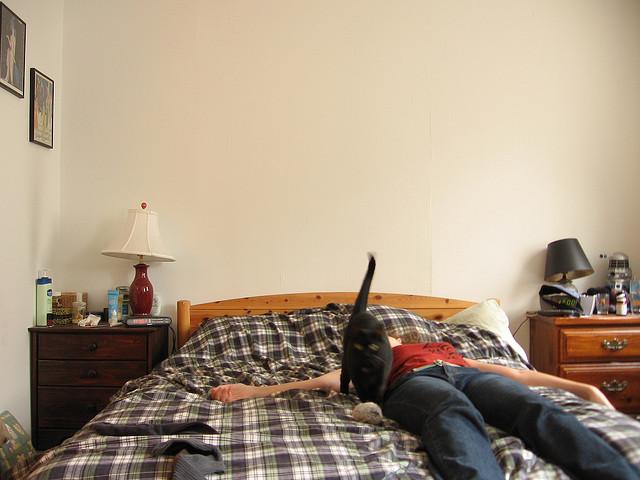What gender is the person?
Keep it brief. Female. How many lamp shades are straight?
Short answer required. 0. Is the person resting?
Concise answer only. Yes. 